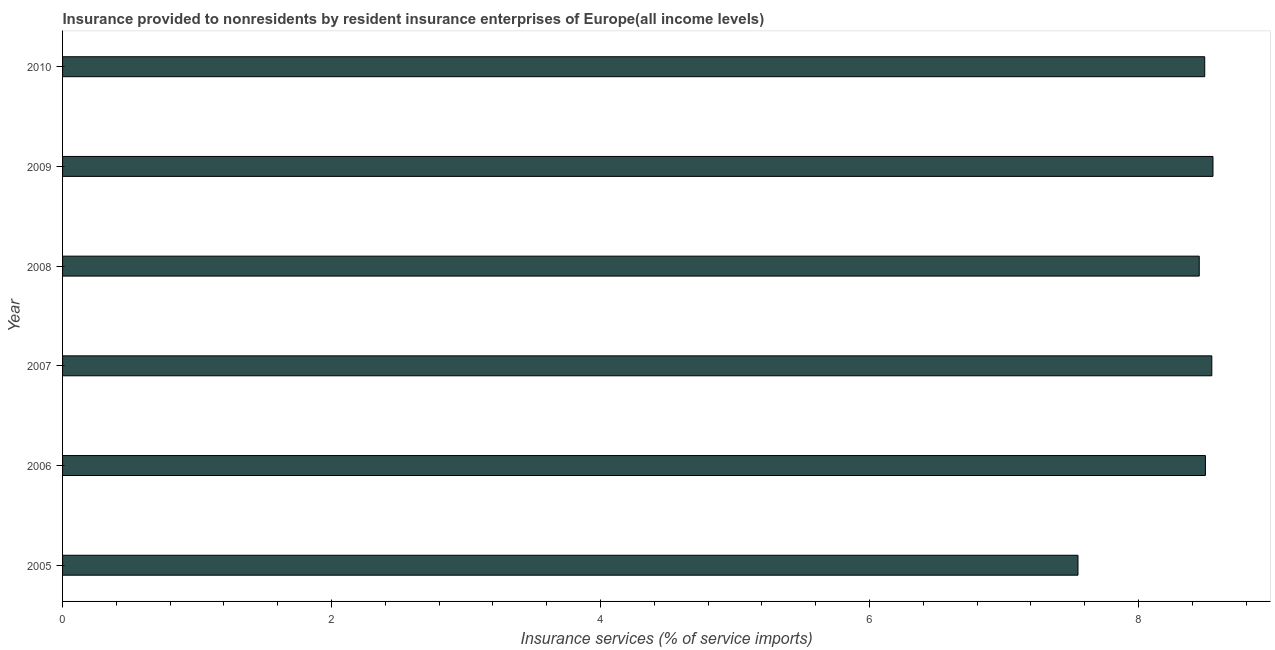What is the title of the graph?
Your answer should be compact. Insurance provided to nonresidents by resident insurance enterprises of Europe(all income levels). What is the label or title of the X-axis?
Give a very brief answer. Insurance services (% of service imports). What is the insurance and financial services in 2006?
Your answer should be compact. 8.5. Across all years, what is the maximum insurance and financial services?
Offer a terse response. 8.55. Across all years, what is the minimum insurance and financial services?
Your answer should be compact. 7.55. In which year was the insurance and financial services maximum?
Your answer should be very brief. 2009. What is the sum of the insurance and financial services?
Keep it short and to the point. 50.09. What is the difference between the insurance and financial services in 2005 and 2008?
Ensure brevity in your answer.  -0.9. What is the average insurance and financial services per year?
Keep it short and to the point. 8.35. What is the median insurance and financial services?
Give a very brief answer. 8.5. Do a majority of the years between 2010 and 2007 (inclusive) have insurance and financial services greater than 4.8 %?
Ensure brevity in your answer.  Yes. What is the ratio of the insurance and financial services in 2007 to that in 2008?
Ensure brevity in your answer.  1.01. Is the difference between the insurance and financial services in 2006 and 2009 greater than the difference between any two years?
Provide a short and direct response. No. What is the difference between the highest and the second highest insurance and financial services?
Your response must be concise. 0.01. Is the sum of the insurance and financial services in 2007 and 2009 greater than the maximum insurance and financial services across all years?
Your response must be concise. Yes. What is the difference between the highest and the lowest insurance and financial services?
Offer a very short reply. 1. How many bars are there?
Offer a terse response. 6. What is the difference between two consecutive major ticks on the X-axis?
Offer a terse response. 2. What is the Insurance services (% of service imports) in 2005?
Your response must be concise. 7.55. What is the Insurance services (% of service imports) in 2006?
Make the answer very short. 8.5. What is the Insurance services (% of service imports) in 2007?
Your answer should be compact. 8.55. What is the Insurance services (% of service imports) in 2008?
Give a very brief answer. 8.45. What is the Insurance services (% of service imports) of 2009?
Your answer should be very brief. 8.55. What is the Insurance services (% of service imports) in 2010?
Give a very brief answer. 8.49. What is the difference between the Insurance services (% of service imports) in 2005 and 2006?
Give a very brief answer. -0.95. What is the difference between the Insurance services (% of service imports) in 2005 and 2007?
Provide a succinct answer. -1. What is the difference between the Insurance services (% of service imports) in 2005 and 2008?
Your response must be concise. -0.9. What is the difference between the Insurance services (% of service imports) in 2005 and 2009?
Provide a short and direct response. -1. What is the difference between the Insurance services (% of service imports) in 2005 and 2010?
Provide a succinct answer. -0.94. What is the difference between the Insurance services (% of service imports) in 2006 and 2007?
Ensure brevity in your answer.  -0.05. What is the difference between the Insurance services (% of service imports) in 2006 and 2008?
Give a very brief answer. 0.05. What is the difference between the Insurance services (% of service imports) in 2006 and 2009?
Provide a short and direct response. -0.06. What is the difference between the Insurance services (% of service imports) in 2006 and 2010?
Make the answer very short. 0.01. What is the difference between the Insurance services (% of service imports) in 2007 and 2008?
Give a very brief answer. 0.09. What is the difference between the Insurance services (% of service imports) in 2007 and 2009?
Ensure brevity in your answer.  -0.01. What is the difference between the Insurance services (% of service imports) in 2007 and 2010?
Your answer should be compact. 0.05. What is the difference between the Insurance services (% of service imports) in 2008 and 2009?
Your answer should be compact. -0.1. What is the difference between the Insurance services (% of service imports) in 2008 and 2010?
Your answer should be very brief. -0.04. What is the difference between the Insurance services (% of service imports) in 2009 and 2010?
Your answer should be compact. 0.06. What is the ratio of the Insurance services (% of service imports) in 2005 to that in 2006?
Your answer should be compact. 0.89. What is the ratio of the Insurance services (% of service imports) in 2005 to that in 2007?
Make the answer very short. 0.88. What is the ratio of the Insurance services (% of service imports) in 2005 to that in 2008?
Offer a very short reply. 0.89. What is the ratio of the Insurance services (% of service imports) in 2005 to that in 2009?
Your answer should be very brief. 0.88. What is the ratio of the Insurance services (% of service imports) in 2005 to that in 2010?
Your response must be concise. 0.89. What is the ratio of the Insurance services (% of service imports) in 2006 to that in 2008?
Ensure brevity in your answer.  1. What is the ratio of the Insurance services (% of service imports) in 2006 to that in 2009?
Your answer should be very brief. 0.99. What is the ratio of the Insurance services (% of service imports) in 2006 to that in 2010?
Your answer should be compact. 1. What is the ratio of the Insurance services (% of service imports) in 2008 to that in 2009?
Offer a terse response. 0.99. What is the ratio of the Insurance services (% of service imports) in 2009 to that in 2010?
Give a very brief answer. 1.01. 